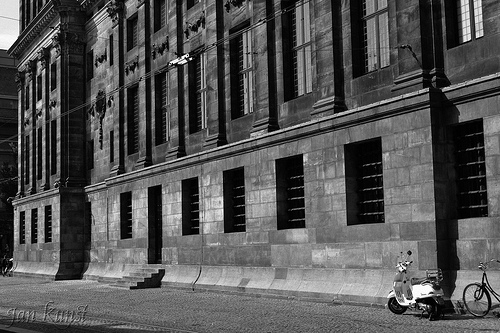What's in front of the doorway? Stairs are in front of the doorway. 